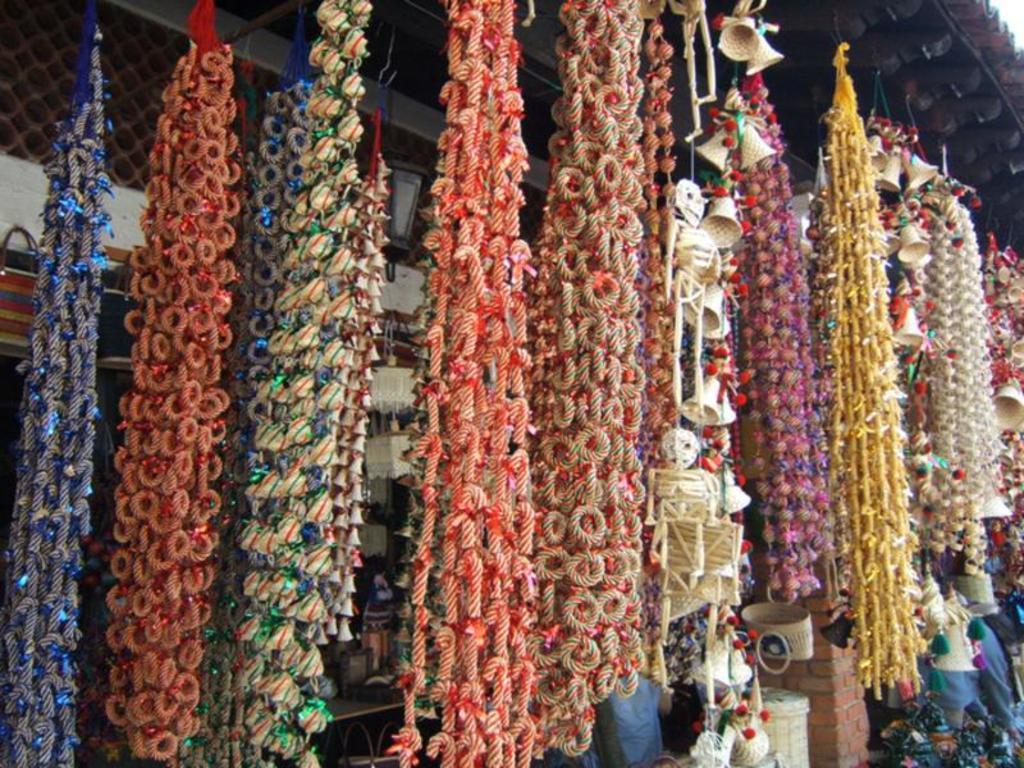Describe this image in one or two sentences. In this image, we can see decors, which are made with threads and are hanging and we can see some other baskets, racks and there is a wall. At the top, there is roof. 